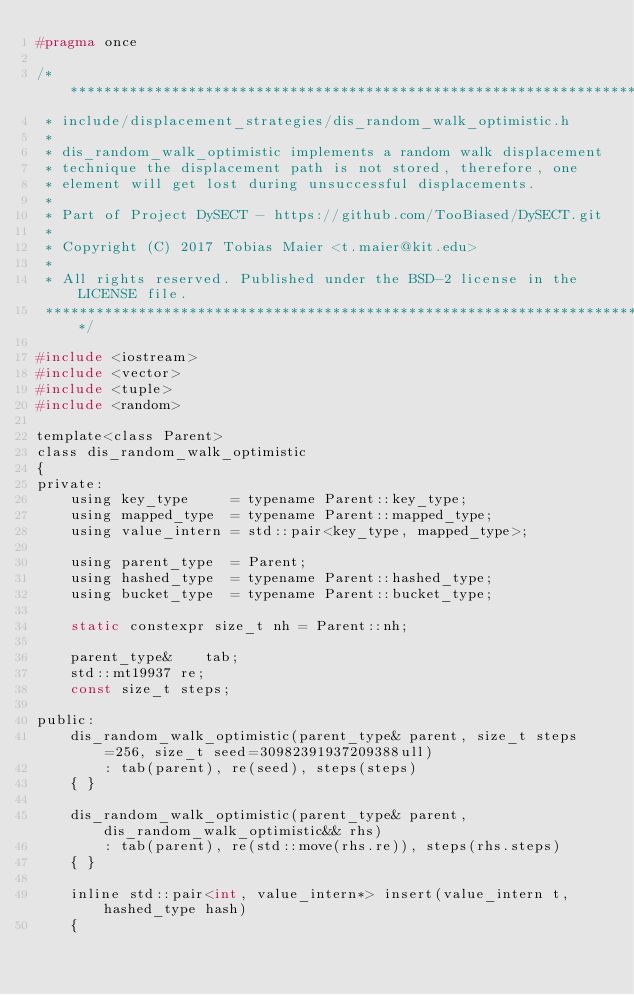Convert code to text. <code><loc_0><loc_0><loc_500><loc_500><_C_>#pragma once

/*******************************************************************************
 * include/displacement_strategies/dis_random_walk_optimistic.h
 *
 * dis_random_walk_optimistic implements a random walk displacement
 * technique the displacement path is not stored, therefore, one
 * element will get lost during unsuccessful displacements.
 *
 * Part of Project DySECT - https://github.com/TooBiased/DySECT.git
 *
 * Copyright (C) 2017 Tobias Maier <t.maier@kit.edu>
 *
 * All rights reserved. Published under the BSD-2 license in the LICENSE file.
 ******************************************************************************/

#include <iostream>
#include <vector>
#include <tuple>
#include <random>

template<class Parent>
class dis_random_walk_optimistic
{
private:
    using key_type     = typename Parent::key_type;
    using mapped_type  = typename Parent::mapped_type;
    using value_intern = std::pair<key_type, mapped_type>;

    using parent_type  = Parent;
    using hashed_type  = typename Parent::hashed_type;
    using bucket_type  = typename Parent::bucket_type;

    static constexpr size_t nh = Parent::nh;

    parent_type&    tab;
    std::mt19937 re;
    const size_t steps;

public:
    dis_random_walk_optimistic(parent_type& parent, size_t steps=256, size_t seed=30982391937209388ull)
        : tab(parent), re(seed), steps(steps)
    { }

    dis_random_walk_optimistic(parent_type& parent, dis_random_walk_optimistic&& rhs)
        : tab(parent), re(std::move(rhs.re)), steps(rhs.steps)
    { }

    inline std::pair<int, value_intern*> insert(value_intern t, hashed_type hash)
    {</code> 